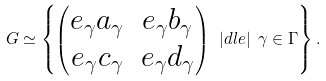Convert formula to latex. <formula><loc_0><loc_0><loc_500><loc_500>G \simeq \left \{ \begin{pmatrix} e _ { \gamma } a _ { \gamma } & e _ { \gamma } b _ { \gamma } \\ e _ { \gamma } c _ { \gamma } & e _ { \gamma } d _ { \gamma } \end{pmatrix} \ | d l e | \ \gamma \in \Gamma \right \} .</formula> 